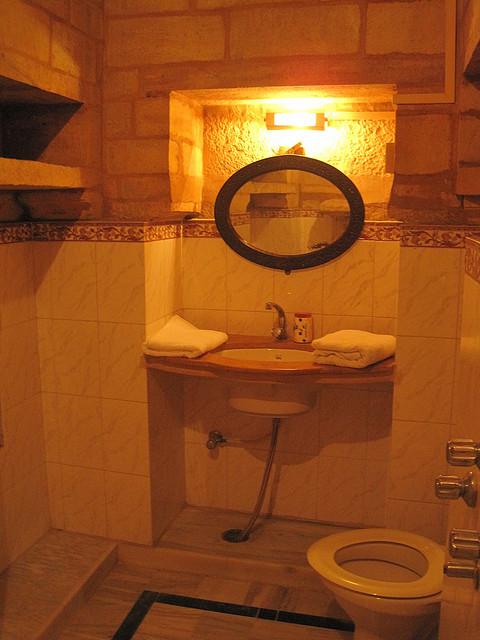How is the mirror shaped?
Quick response, please. Oval. Is the toilet seat up?
Answer briefly. No. Is the water basin enclosed?
Answer briefly. No. 